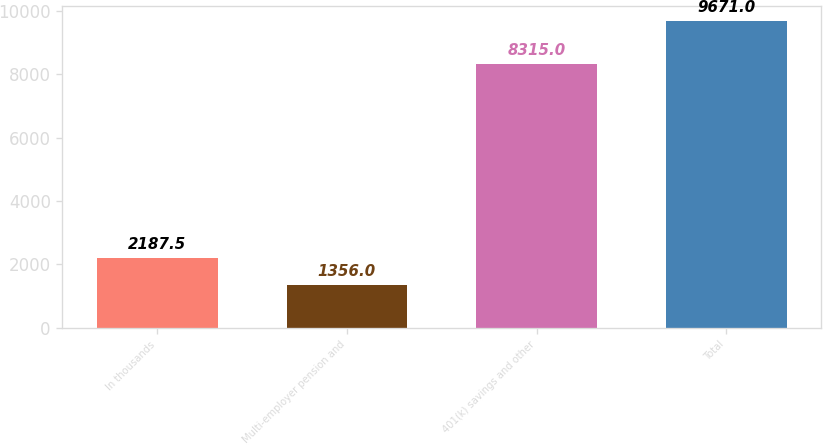Convert chart to OTSL. <chart><loc_0><loc_0><loc_500><loc_500><bar_chart><fcel>In thousands<fcel>Multi-employer pension and<fcel>401(k) savings and other<fcel>Total<nl><fcel>2187.5<fcel>1356<fcel>8315<fcel>9671<nl></chart> 